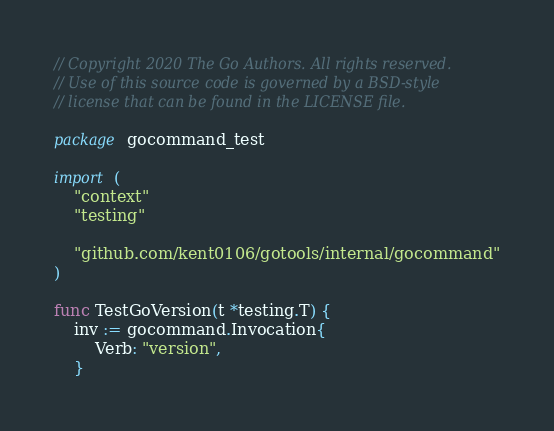<code> <loc_0><loc_0><loc_500><loc_500><_Go_>// Copyright 2020 The Go Authors. All rights reserved.
// Use of this source code is governed by a BSD-style
// license that can be found in the LICENSE file.

package gocommand_test

import (
	"context"
	"testing"

	"github.com/kent0106/gotools/internal/gocommand"
)

func TestGoVersion(t *testing.T) {
	inv := gocommand.Invocation{
		Verb: "version",
	}</code> 